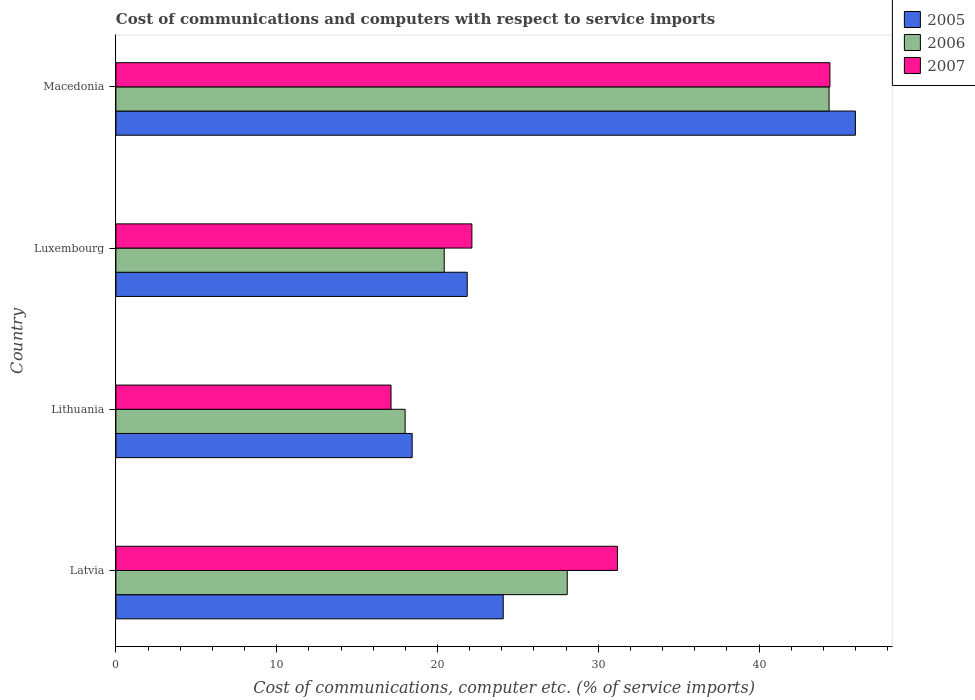How many different coloured bars are there?
Give a very brief answer. 3. How many groups of bars are there?
Your response must be concise. 4. How many bars are there on the 2nd tick from the top?
Offer a very short reply. 3. What is the label of the 4th group of bars from the top?
Make the answer very short. Latvia. What is the cost of communications and computers in 2006 in Latvia?
Offer a terse response. 28.07. Across all countries, what is the maximum cost of communications and computers in 2007?
Provide a succinct answer. 44.41. Across all countries, what is the minimum cost of communications and computers in 2005?
Offer a terse response. 18.43. In which country was the cost of communications and computers in 2006 maximum?
Make the answer very short. Macedonia. In which country was the cost of communications and computers in 2006 minimum?
Make the answer very short. Lithuania. What is the total cost of communications and computers in 2006 in the graph?
Ensure brevity in your answer.  110.83. What is the difference between the cost of communications and computers in 2005 in Luxembourg and that in Macedonia?
Keep it short and to the point. -24.14. What is the difference between the cost of communications and computers in 2006 in Lithuania and the cost of communications and computers in 2005 in Latvia?
Your response must be concise. -6.1. What is the average cost of communications and computers in 2005 per country?
Keep it short and to the point. 27.59. What is the difference between the cost of communications and computers in 2006 and cost of communications and computers in 2005 in Latvia?
Provide a succinct answer. 3.98. What is the ratio of the cost of communications and computers in 2007 in Lithuania to that in Luxembourg?
Your answer should be compact. 0.77. Is the cost of communications and computers in 2006 in Latvia less than that in Luxembourg?
Make the answer very short. No. Is the difference between the cost of communications and computers in 2006 in Latvia and Macedonia greater than the difference between the cost of communications and computers in 2005 in Latvia and Macedonia?
Your answer should be very brief. Yes. What is the difference between the highest and the second highest cost of communications and computers in 2007?
Your answer should be very brief. 13.22. What is the difference between the highest and the lowest cost of communications and computers in 2006?
Provide a succinct answer. 26.37. Is the sum of the cost of communications and computers in 2005 in Latvia and Luxembourg greater than the maximum cost of communications and computers in 2007 across all countries?
Your response must be concise. Yes. What does the 3rd bar from the bottom in Lithuania represents?
Ensure brevity in your answer.  2007. Is it the case that in every country, the sum of the cost of communications and computers in 2007 and cost of communications and computers in 2006 is greater than the cost of communications and computers in 2005?
Offer a terse response. Yes. How many bars are there?
Provide a short and direct response. 12. Are all the bars in the graph horizontal?
Your response must be concise. Yes. How many countries are there in the graph?
Offer a terse response. 4. Does the graph contain any zero values?
Give a very brief answer. No. Where does the legend appear in the graph?
Give a very brief answer. Top right. How are the legend labels stacked?
Make the answer very short. Vertical. What is the title of the graph?
Your answer should be compact. Cost of communications and computers with respect to service imports. What is the label or title of the X-axis?
Your answer should be very brief. Cost of communications, computer etc. (% of service imports). What is the label or title of the Y-axis?
Make the answer very short. Country. What is the Cost of communications, computer etc. (% of service imports) of 2005 in Latvia?
Ensure brevity in your answer.  24.09. What is the Cost of communications, computer etc. (% of service imports) of 2006 in Latvia?
Keep it short and to the point. 28.07. What is the Cost of communications, computer etc. (% of service imports) of 2007 in Latvia?
Your response must be concise. 31.19. What is the Cost of communications, computer etc. (% of service imports) in 2005 in Lithuania?
Provide a short and direct response. 18.43. What is the Cost of communications, computer etc. (% of service imports) of 2006 in Lithuania?
Offer a very short reply. 17.99. What is the Cost of communications, computer etc. (% of service imports) of 2007 in Lithuania?
Provide a short and direct response. 17.11. What is the Cost of communications, computer etc. (% of service imports) of 2005 in Luxembourg?
Your response must be concise. 21.85. What is the Cost of communications, computer etc. (% of service imports) of 2006 in Luxembourg?
Your answer should be compact. 20.42. What is the Cost of communications, computer etc. (% of service imports) of 2007 in Luxembourg?
Give a very brief answer. 22.14. What is the Cost of communications, computer etc. (% of service imports) of 2005 in Macedonia?
Your answer should be compact. 45.99. What is the Cost of communications, computer etc. (% of service imports) in 2006 in Macedonia?
Offer a terse response. 44.35. What is the Cost of communications, computer etc. (% of service imports) in 2007 in Macedonia?
Ensure brevity in your answer.  44.41. Across all countries, what is the maximum Cost of communications, computer etc. (% of service imports) in 2005?
Ensure brevity in your answer.  45.99. Across all countries, what is the maximum Cost of communications, computer etc. (% of service imports) in 2006?
Ensure brevity in your answer.  44.35. Across all countries, what is the maximum Cost of communications, computer etc. (% of service imports) in 2007?
Make the answer very short. 44.41. Across all countries, what is the minimum Cost of communications, computer etc. (% of service imports) in 2005?
Offer a very short reply. 18.43. Across all countries, what is the minimum Cost of communications, computer etc. (% of service imports) in 2006?
Your answer should be very brief. 17.99. Across all countries, what is the minimum Cost of communications, computer etc. (% of service imports) of 2007?
Offer a terse response. 17.11. What is the total Cost of communications, computer etc. (% of service imports) in 2005 in the graph?
Offer a very short reply. 110.36. What is the total Cost of communications, computer etc. (% of service imports) in 2006 in the graph?
Offer a terse response. 110.83. What is the total Cost of communications, computer etc. (% of service imports) of 2007 in the graph?
Your response must be concise. 114.85. What is the difference between the Cost of communications, computer etc. (% of service imports) in 2005 in Latvia and that in Lithuania?
Give a very brief answer. 5.66. What is the difference between the Cost of communications, computer etc. (% of service imports) in 2006 in Latvia and that in Lithuania?
Keep it short and to the point. 10.08. What is the difference between the Cost of communications, computer etc. (% of service imports) in 2007 in Latvia and that in Lithuania?
Your answer should be compact. 14.08. What is the difference between the Cost of communications, computer etc. (% of service imports) in 2005 in Latvia and that in Luxembourg?
Your answer should be compact. 2.24. What is the difference between the Cost of communications, computer etc. (% of service imports) of 2006 in Latvia and that in Luxembourg?
Ensure brevity in your answer.  7.65. What is the difference between the Cost of communications, computer etc. (% of service imports) of 2007 in Latvia and that in Luxembourg?
Provide a short and direct response. 9.05. What is the difference between the Cost of communications, computer etc. (% of service imports) of 2005 in Latvia and that in Macedonia?
Your answer should be compact. -21.9. What is the difference between the Cost of communications, computer etc. (% of service imports) in 2006 in Latvia and that in Macedonia?
Your response must be concise. -16.28. What is the difference between the Cost of communications, computer etc. (% of service imports) in 2007 in Latvia and that in Macedonia?
Offer a very short reply. -13.22. What is the difference between the Cost of communications, computer etc. (% of service imports) in 2005 in Lithuania and that in Luxembourg?
Your response must be concise. -3.42. What is the difference between the Cost of communications, computer etc. (% of service imports) of 2006 in Lithuania and that in Luxembourg?
Your answer should be very brief. -2.43. What is the difference between the Cost of communications, computer etc. (% of service imports) of 2007 in Lithuania and that in Luxembourg?
Provide a short and direct response. -5.03. What is the difference between the Cost of communications, computer etc. (% of service imports) in 2005 in Lithuania and that in Macedonia?
Keep it short and to the point. -27.57. What is the difference between the Cost of communications, computer etc. (% of service imports) of 2006 in Lithuania and that in Macedonia?
Keep it short and to the point. -26.37. What is the difference between the Cost of communications, computer etc. (% of service imports) in 2007 in Lithuania and that in Macedonia?
Your response must be concise. -27.3. What is the difference between the Cost of communications, computer etc. (% of service imports) in 2005 in Luxembourg and that in Macedonia?
Make the answer very short. -24.14. What is the difference between the Cost of communications, computer etc. (% of service imports) of 2006 in Luxembourg and that in Macedonia?
Offer a very short reply. -23.93. What is the difference between the Cost of communications, computer etc. (% of service imports) in 2007 in Luxembourg and that in Macedonia?
Give a very brief answer. -22.27. What is the difference between the Cost of communications, computer etc. (% of service imports) in 2005 in Latvia and the Cost of communications, computer etc. (% of service imports) in 2006 in Lithuania?
Offer a terse response. 6.1. What is the difference between the Cost of communications, computer etc. (% of service imports) of 2005 in Latvia and the Cost of communications, computer etc. (% of service imports) of 2007 in Lithuania?
Make the answer very short. 6.98. What is the difference between the Cost of communications, computer etc. (% of service imports) in 2006 in Latvia and the Cost of communications, computer etc. (% of service imports) in 2007 in Lithuania?
Your answer should be very brief. 10.96. What is the difference between the Cost of communications, computer etc. (% of service imports) of 2005 in Latvia and the Cost of communications, computer etc. (% of service imports) of 2006 in Luxembourg?
Provide a short and direct response. 3.67. What is the difference between the Cost of communications, computer etc. (% of service imports) of 2005 in Latvia and the Cost of communications, computer etc. (% of service imports) of 2007 in Luxembourg?
Your response must be concise. 1.95. What is the difference between the Cost of communications, computer etc. (% of service imports) of 2006 in Latvia and the Cost of communications, computer etc. (% of service imports) of 2007 in Luxembourg?
Your answer should be compact. 5.93. What is the difference between the Cost of communications, computer etc. (% of service imports) of 2005 in Latvia and the Cost of communications, computer etc. (% of service imports) of 2006 in Macedonia?
Your answer should be compact. -20.26. What is the difference between the Cost of communications, computer etc. (% of service imports) of 2005 in Latvia and the Cost of communications, computer etc. (% of service imports) of 2007 in Macedonia?
Ensure brevity in your answer.  -20.32. What is the difference between the Cost of communications, computer etc. (% of service imports) in 2006 in Latvia and the Cost of communications, computer etc. (% of service imports) in 2007 in Macedonia?
Offer a terse response. -16.34. What is the difference between the Cost of communications, computer etc. (% of service imports) of 2005 in Lithuania and the Cost of communications, computer etc. (% of service imports) of 2006 in Luxembourg?
Your response must be concise. -1.99. What is the difference between the Cost of communications, computer etc. (% of service imports) of 2005 in Lithuania and the Cost of communications, computer etc. (% of service imports) of 2007 in Luxembourg?
Provide a short and direct response. -3.72. What is the difference between the Cost of communications, computer etc. (% of service imports) in 2006 in Lithuania and the Cost of communications, computer etc. (% of service imports) in 2007 in Luxembourg?
Give a very brief answer. -4.15. What is the difference between the Cost of communications, computer etc. (% of service imports) of 2005 in Lithuania and the Cost of communications, computer etc. (% of service imports) of 2006 in Macedonia?
Your answer should be compact. -25.93. What is the difference between the Cost of communications, computer etc. (% of service imports) of 2005 in Lithuania and the Cost of communications, computer etc. (% of service imports) of 2007 in Macedonia?
Provide a succinct answer. -25.98. What is the difference between the Cost of communications, computer etc. (% of service imports) of 2006 in Lithuania and the Cost of communications, computer etc. (% of service imports) of 2007 in Macedonia?
Ensure brevity in your answer.  -26.42. What is the difference between the Cost of communications, computer etc. (% of service imports) in 2005 in Luxembourg and the Cost of communications, computer etc. (% of service imports) in 2006 in Macedonia?
Your answer should be compact. -22.5. What is the difference between the Cost of communications, computer etc. (% of service imports) of 2005 in Luxembourg and the Cost of communications, computer etc. (% of service imports) of 2007 in Macedonia?
Offer a terse response. -22.56. What is the difference between the Cost of communications, computer etc. (% of service imports) of 2006 in Luxembourg and the Cost of communications, computer etc. (% of service imports) of 2007 in Macedonia?
Your answer should be very brief. -23.99. What is the average Cost of communications, computer etc. (% of service imports) in 2005 per country?
Provide a succinct answer. 27.59. What is the average Cost of communications, computer etc. (% of service imports) of 2006 per country?
Your answer should be very brief. 27.71. What is the average Cost of communications, computer etc. (% of service imports) in 2007 per country?
Give a very brief answer. 28.71. What is the difference between the Cost of communications, computer etc. (% of service imports) in 2005 and Cost of communications, computer etc. (% of service imports) in 2006 in Latvia?
Keep it short and to the point. -3.98. What is the difference between the Cost of communications, computer etc. (% of service imports) in 2005 and Cost of communications, computer etc. (% of service imports) in 2007 in Latvia?
Offer a very short reply. -7.1. What is the difference between the Cost of communications, computer etc. (% of service imports) of 2006 and Cost of communications, computer etc. (% of service imports) of 2007 in Latvia?
Your response must be concise. -3.12. What is the difference between the Cost of communications, computer etc. (% of service imports) in 2005 and Cost of communications, computer etc. (% of service imports) in 2006 in Lithuania?
Your answer should be compact. 0.44. What is the difference between the Cost of communications, computer etc. (% of service imports) in 2005 and Cost of communications, computer etc. (% of service imports) in 2007 in Lithuania?
Ensure brevity in your answer.  1.31. What is the difference between the Cost of communications, computer etc. (% of service imports) in 2006 and Cost of communications, computer etc. (% of service imports) in 2007 in Lithuania?
Provide a succinct answer. 0.88. What is the difference between the Cost of communications, computer etc. (% of service imports) of 2005 and Cost of communications, computer etc. (% of service imports) of 2006 in Luxembourg?
Provide a succinct answer. 1.43. What is the difference between the Cost of communications, computer etc. (% of service imports) in 2005 and Cost of communications, computer etc. (% of service imports) in 2007 in Luxembourg?
Your answer should be very brief. -0.29. What is the difference between the Cost of communications, computer etc. (% of service imports) in 2006 and Cost of communications, computer etc. (% of service imports) in 2007 in Luxembourg?
Offer a terse response. -1.72. What is the difference between the Cost of communications, computer etc. (% of service imports) in 2005 and Cost of communications, computer etc. (% of service imports) in 2006 in Macedonia?
Keep it short and to the point. 1.64. What is the difference between the Cost of communications, computer etc. (% of service imports) in 2005 and Cost of communications, computer etc. (% of service imports) in 2007 in Macedonia?
Provide a short and direct response. 1.58. What is the difference between the Cost of communications, computer etc. (% of service imports) of 2006 and Cost of communications, computer etc. (% of service imports) of 2007 in Macedonia?
Provide a succinct answer. -0.05. What is the ratio of the Cost of communications, computer etc. (% of service imports) in 2005 in Latvia to that in Lithuania?
Make the answer very short. 1.31. What is the ratio of the Cost of communications, computer etc. (% of service imports) of 2006 in Latvia to that in Lithuania?
Provide a succinct answer. 1.56. What is the ratio of the Cost of communications, computer etc. (% of service imports) of 2007 in Latvia to that in Lithuania?
Ensure brevity in your answer.  1.82. What is the ratio of the Cost of communications, computer etc. (% of service imports) of 2005 in Latvia to that in Luxembourg?
Your answer should be very brief. 1.1. What is the ratio of the Cost of communications, computer etc. (% of service imports) in 2006 in Latvia to that in Luxembourg?
Your response must be concise. 1.37. What is the ratio of the Cost of communications, computer etc. (% of service imports) of 2007 in Latvia to that in Luxembourg?
Ensure brevity in your answer.  1.41. What is the ratio of the Cost of communications, computer etc. (% of service imports) in 2005 in Latvia to that in Macedonia?
Give a very brief answer. 0.52. What is the ratio of the Cost of communications, computer etc. (% of service imports) of 2006 in Latvia to that in Macedonia?
Make the answer very short. 0.63. What is the ratio of the Cost of communications, computer etc. (% of service imports) of 2007 in Latvia to that in Macedonia?
Your answer should be compact. 0.7. What is the ratio of the Cost of communications, computer etc. (% of service imports) of 2005 in Lithuania to that in Luxembourg?
Provide a short and direct response. 0.84. What is the ratio of the Cost of communications, computer etc. (% of service imports) of 2006 in Lithuania to that in Luxembourg?
Give a very brief answer. 0.88. What is the ratio of the Cost of communications, computer etc. (% of service imports) of 2007 in Lithuania to that in Luxembourg?
Offer a very short reply. 0.77. What is the ratio of the Cost of communications, computer etc. (% of service imports) of 2005 in Lithuania to that in Macedonia?
Your response must be concise. 0.4. What is the ratio of the Cost of communications, computer etc. (% of service imports) of 2006 in Lithuania to that in Macedonia?
Provide a short and direct response. 0.41. What is the ratio of the Cost of communications, computer etc. (% of service imports) of 2007 in Lithuania to that in Macedonia?
Make the answer very short. 0.39. What is the ratio of the Cost of communications, computer etc. (% of service imports) in 2005 in Luxembourg to that in Macedonia?
Ensure brevity in your answer.  0.48. What is the ratio of the Cost of communications, computer etc. (% of service imports) of 2006 in Luxembourg to that in Macedonia?
Provide a succinct answer. 0.46. What is the ratio of the Cost of communications, computer etc. (% of service imports) in 2007 in Luxembourg to that in Macedonia?
Provide a succinct answer. 0.5. What is the difference between the highest and the second highest Cost of communications, computer etc. (% of service imports) in 2005?
Provide a short and direct response. 21.9. What is the difference between the highest and the second highest Cost of communications, computer etc. (% of service imports) of 2006?
Your answer should be compact. 16.28. What is the difference between the highest and the second highest Cost of communications, computer etc. (% of service imports) of 2007?
Your answer should be very brief. 13.22. What is the difference between the highest and the lowest Cost of communications, computer etc. (% of service imports) in 2005?
Your response must be concise. 27.57. What is the difference between the highest and the lowest Cost of communications, computer etc. (% of service imports) of 2006?
Make the answer very short. 26.37. What is the difference between the highest and the lowest Cost of communications, computer etc. (% of service imports) of 2007?
Ensure brevity in your answer.  27.3. 